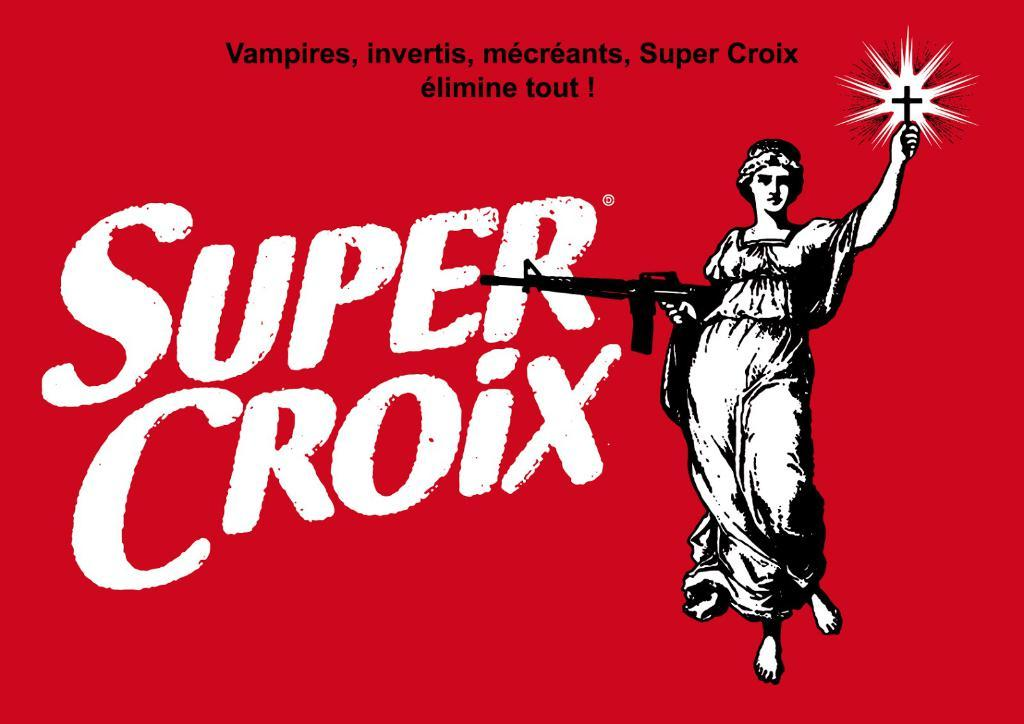<image>
Provide a brief description of the given image. A red sign with Super Croix written in white letters 